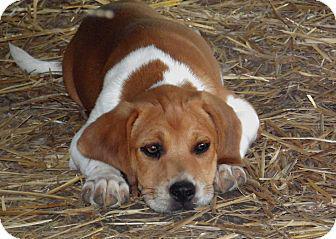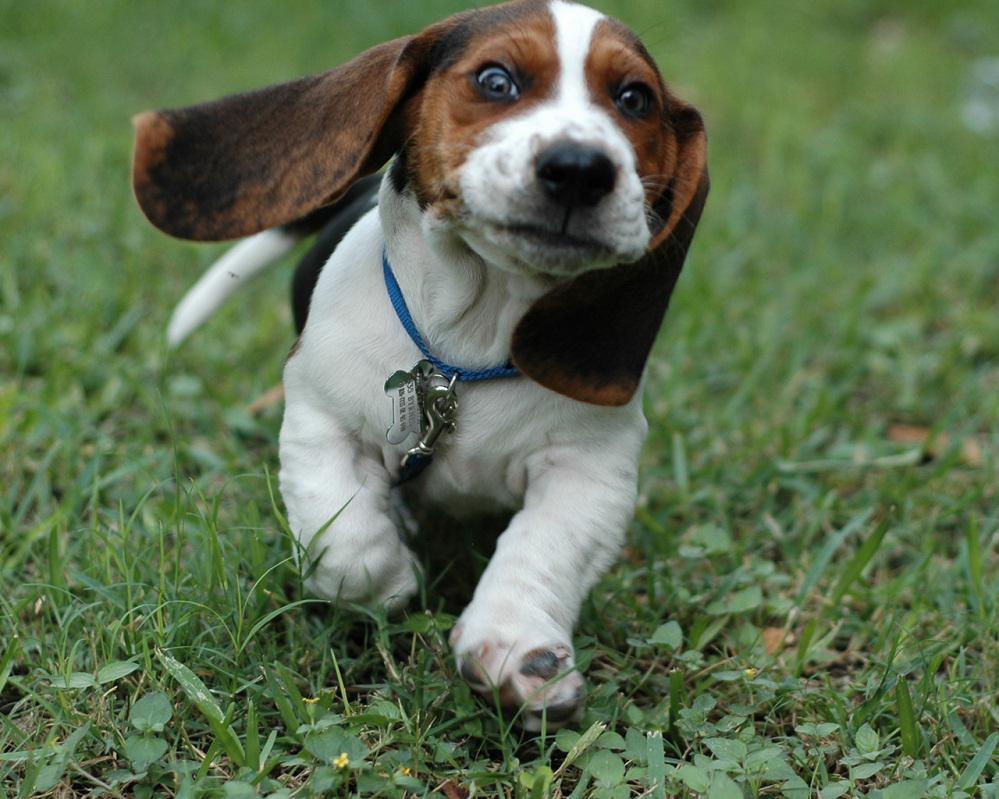The first image is the image on the left, the second image is the image on the right. For the images displayed, is the sentence "There is an image of a tan and white puppy sitting on grass." factually correct? Answer yes or no. No. The first image is the image on the left, the second image is the image on the right. Examine the images to the left and right. Is the description "the right image has a puppy on a grassy surface" accurate? Answer yes or no. Yes. 